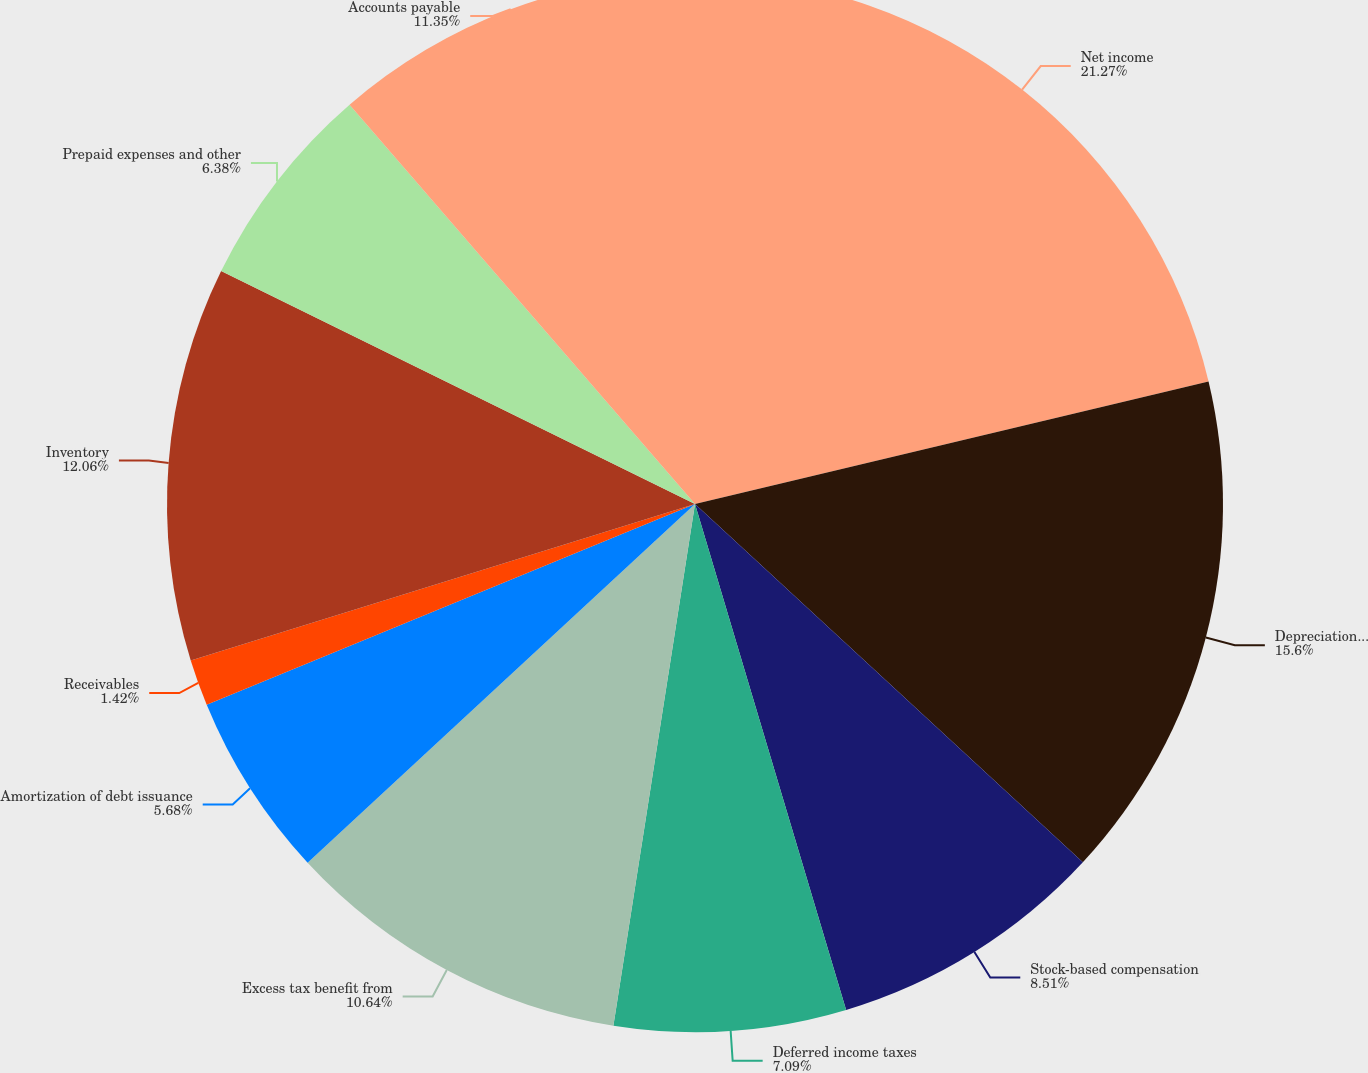Convert chart to OTSL. <chart><loc_0><loc_0><loc_500><loc_500><pie_chart><fcel>Net income<fcel>Depreciation and amortization<fcel>Stock-based compensation<fcel>Deferred income taxes<fcel>Excess tax benefit from<fcel>Amortization of debt issuance<fcel>Receivables<fcel>Inventory<fcel>Prepaid expenses and other<fcel>Accounts payable<nl><fcel>21.27%<fcel>15.6%<fcel>8.51%<fcel>7.09%<fcel>10.64%<fcel>5.68%<fcel>1.42%<fcel>12.06%<fcel>6.38%<fcel>11.35%<nl></chart> 